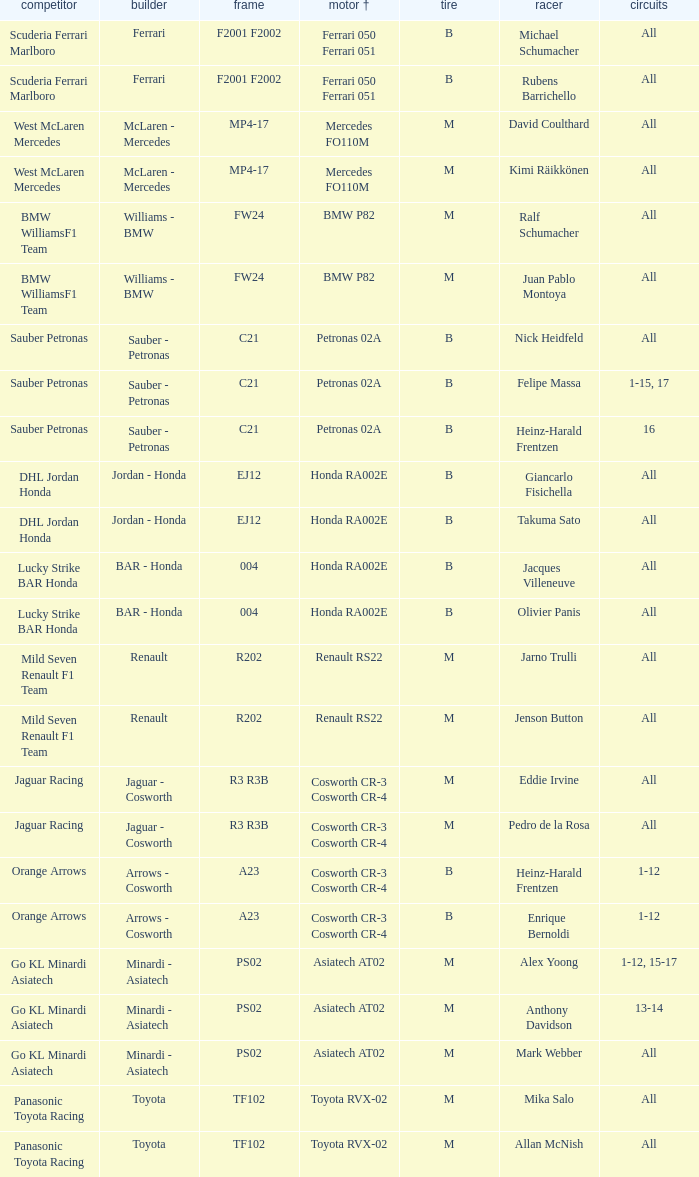Who is the contender when the engine is bmw p82? BMW WilliamsF1 Team, BMW WilliamsF1 Team. 